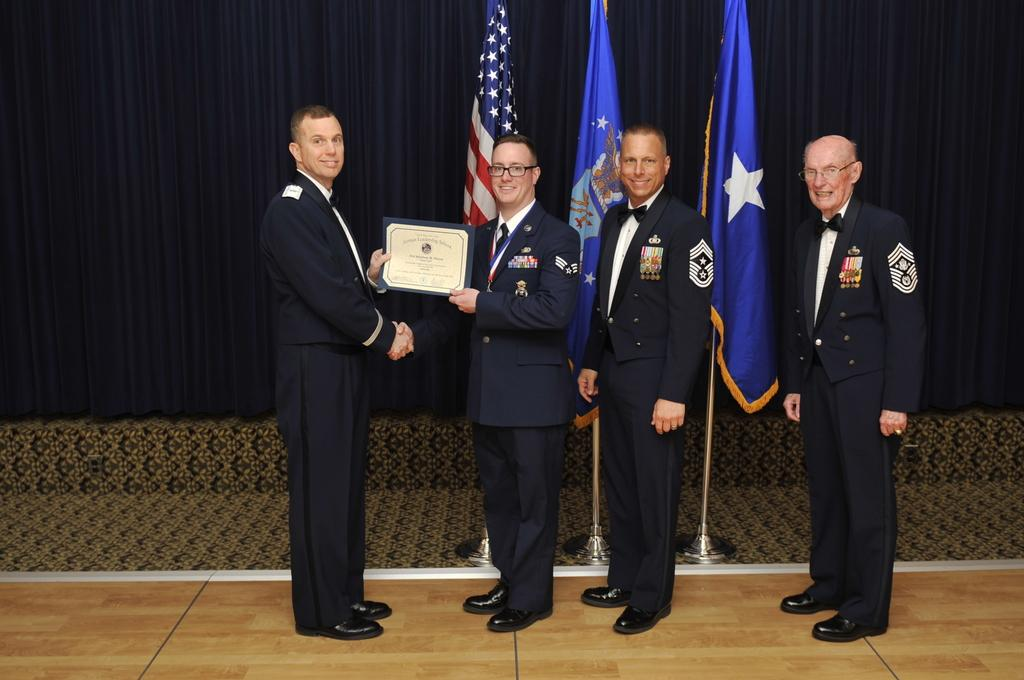How many people are in the group that is visible in the image? There is a group of people in the image, but the exact number is not specified. What can be observed about some of the people in the group? Some people in the group are wearing spectacles. What are some people in the group holding? Some people in the group are holding a certificate. What can be seen in the background of the image? There are flags and curtains visible in the background of the image. What type of tin can be seen on the list held by one of the people in the image? There is no tin or list present in the image. What is the stem of the flower that is being held by one of the people in the image? There is no flower or stem present in the image. 